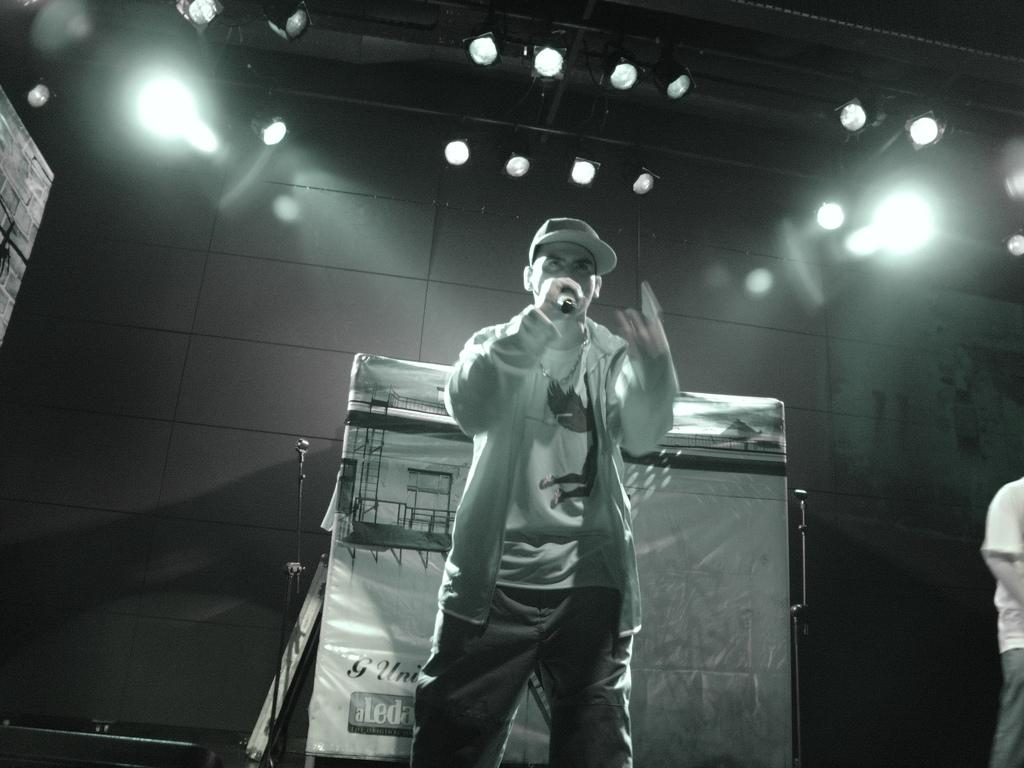What is the color scheme of the image? The image is black and white. Who is the main subject in the image? There is a man in the image. What is the man doing in the image? The man is talking on a microphone. What is the man wearing on his head? The man is wearing a cap. What can be seen in the background of the image? There is a wall and lights visible in the background. What is present in the image that might be related to an event or gathering? There is a banner in the image. How many slaves are visible in the image? There are no slaves present in the image. What type of connection is the man using to talk on the microphone? The image does not provide information about the type of connection being used for the microphone. 